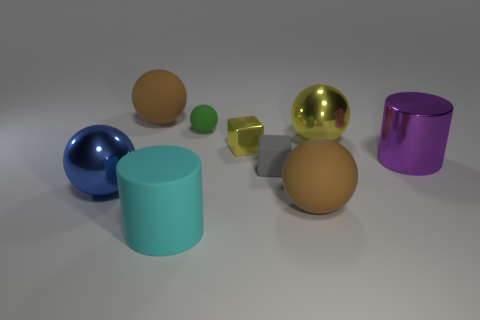How many other things are the same color as the small metallic block? Including the small metallic block itself, there are two objects in the image that share a similar shade of gold—this block and the larger, spherical object. 